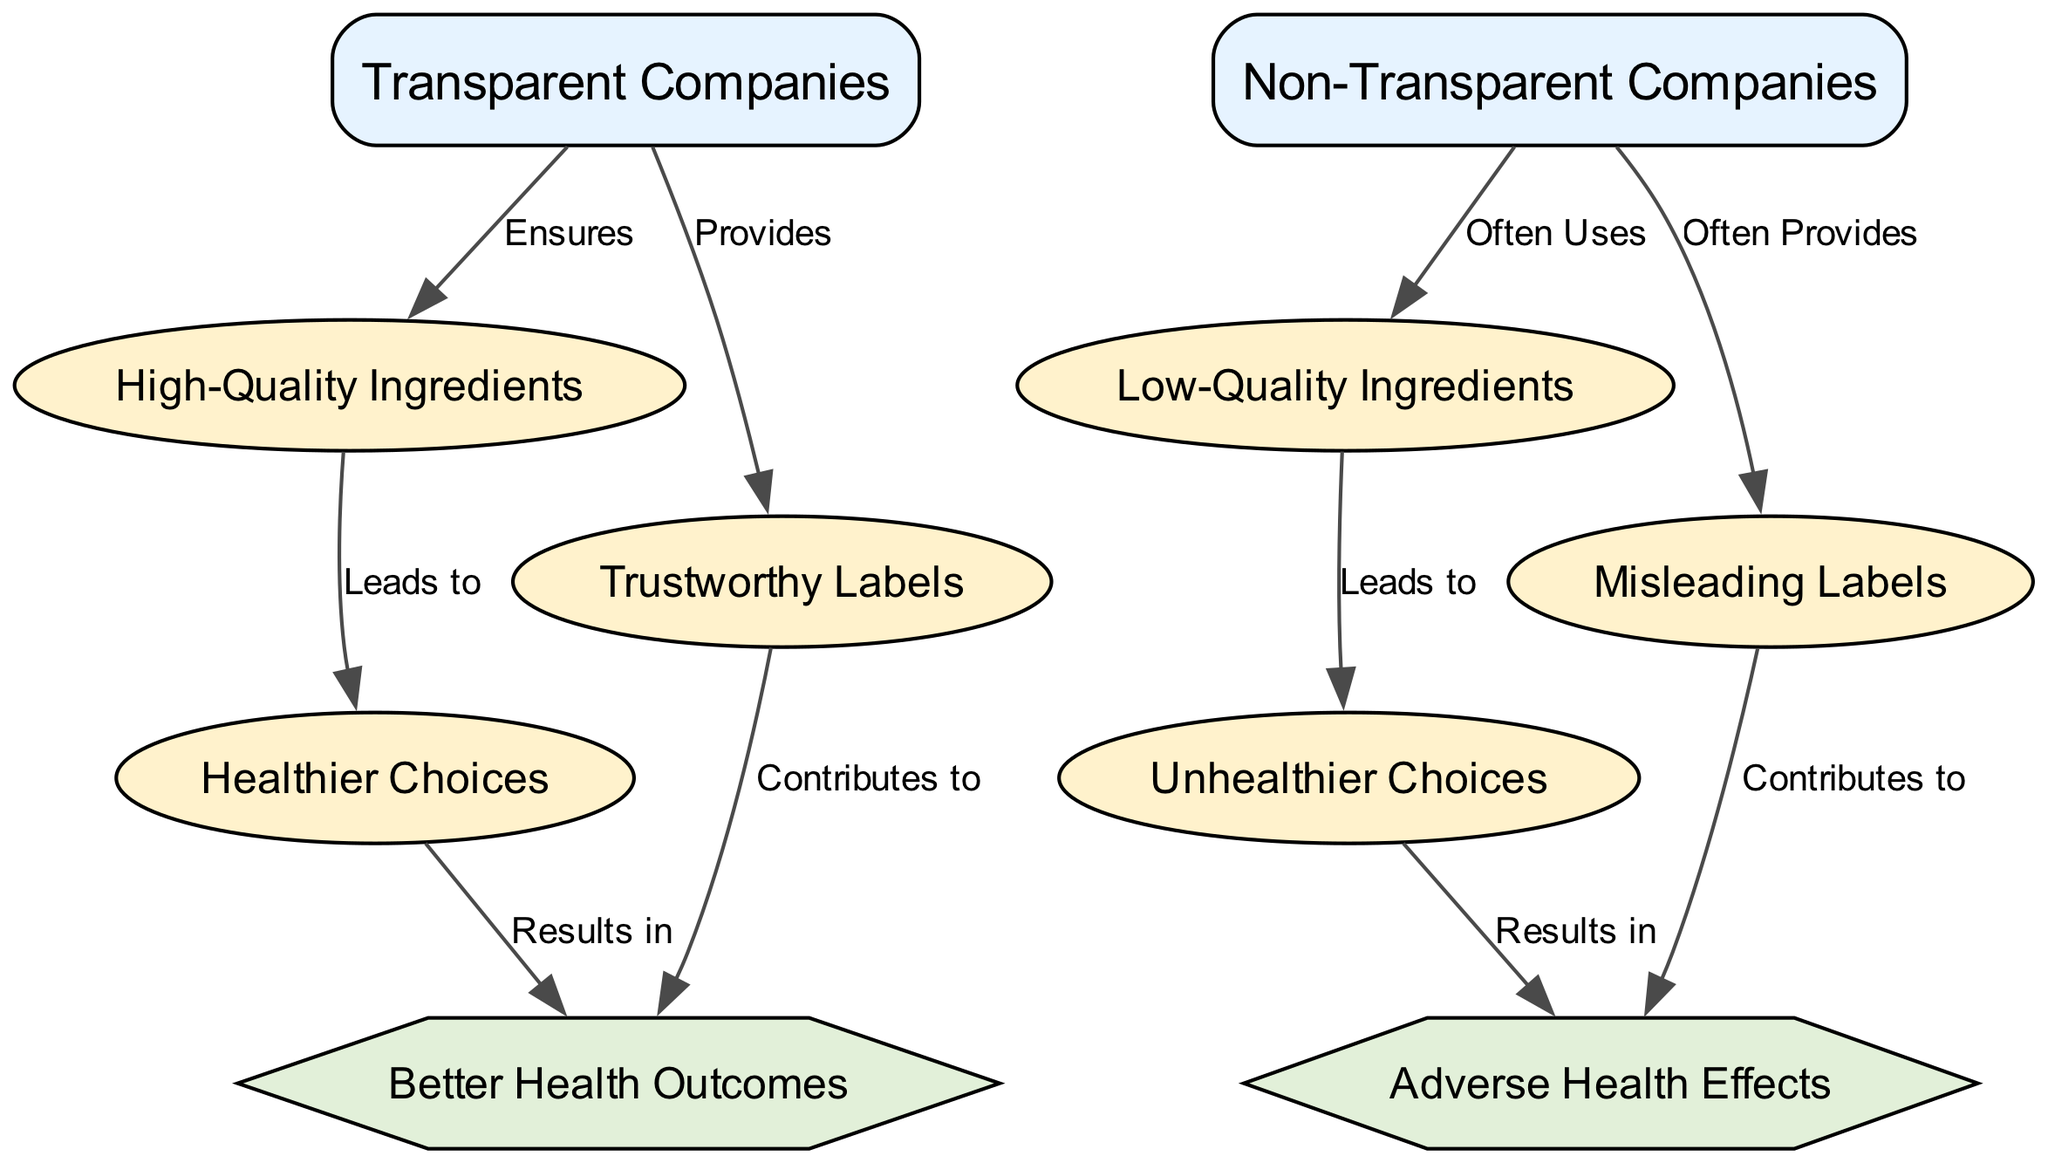What are the two types of companies illustrated in the diagram? The diagram highlights two types of companies: "Transparent Companies" and "Non-Transparent Companies." These are the two entities at the start of the flow chart.
Answer: Transparent Companies, Non-Transparent Companies How many outcomes are shown in the diagram? The diagram presents four outcomes: "High-Quality Ingredients," "Low-Quality Ingredients," "Healthier Choices," and "Unhealthier Choices." Counting these, there are four distinct outcomes.
Answer: 4 What is the relationship between non-transparent companies and low-quality ingredients? The diagram shows that non-transparent companies "Often Uses" low-quality ingredients, indicating a direct association of usage between these two entities.
Answer: Often Uses What do healthier choices lead to according to the diagram? According to the diagram, healthier choices "Results in" Better Health Outcomes, establishing a positive outcome from making healthier choices.
Answer: Better Health Outcomes How do trustworthy labels contribute according to the diagram? The diagram indicates that trustworthy labels "Contributes to" Better Health Outcomes, illustrating the role of honest labeling in achieving favorable health results.
Answer: Contributes to Better Health Outcomes Which outcome is associated with non-transparent companies and misleading labels? The diagram states that misleading labels "Contributes to" Adverse Health Effects, linking them directly to negative outcomes from non-transparent companies.
Answer: Adverse Health Effects What is the source of healthier choices? Healthier choices emerge from high-quality ingredients, as laid out in the diagram, showing a direct pathway from quality to choice.
Answer: High-Quality Ingredients Which type of company ensures high-quality ingredients? The diagram makes it clear that transparent companies "Ensures" high-quality ingredients, highlighting their commitment to quality.
Answer: Ensures What are the two specific outcomes related to health effects? The two specific outcomes related to health effects outlined in the diagram are "Better Health Outcomes" and "Adverse Health Effects," signifying positive and negative impacts respectively.
Answer: Better Health Outcomes, Adverse Health Effects 